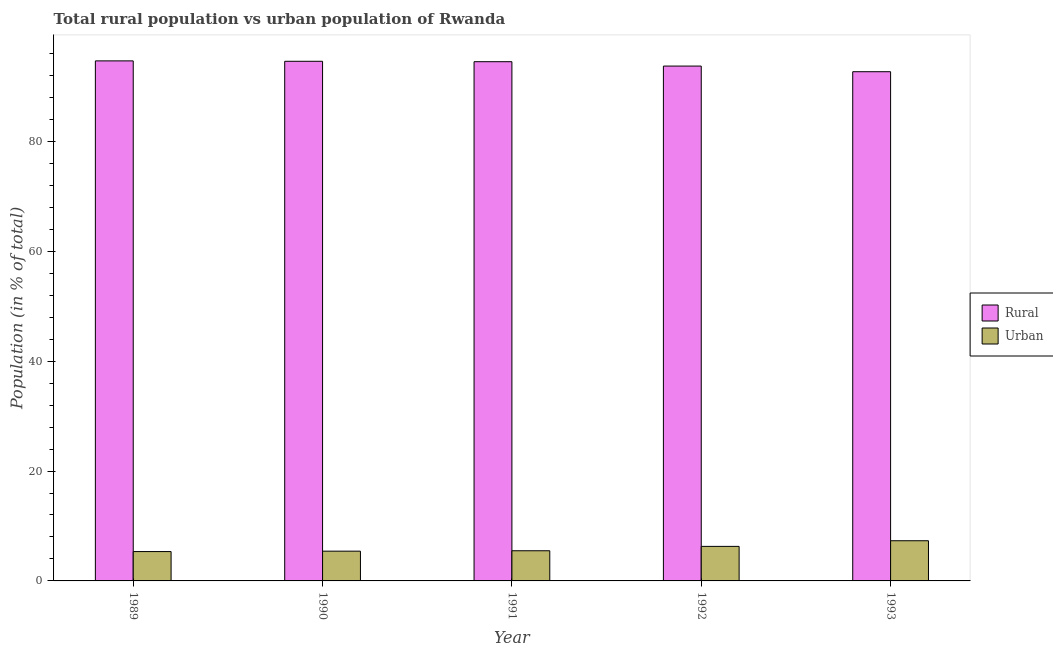How many different coloured bars are there?
Your answer should be compact. 2. How many groups of bars are there?
Give a very brief answer. 5. What is the rural population in 1991?
Keep it short and to the point. 94.51. Across all years, what is the maximum rural population?
Offer a terse response. 94.66. Across all years, what is the minimum urban population?
Provide a succinct answer. 5.34. In which year was the urban population minimum?
Provide a succinct answer. 1989. What is the total urban population in the graph?
Ensure brevity in your answer.  29.85. What is the difference between the rural population in 1992 and that in 1993?
Offer a very short reply. 1.03. What is the difference between the rural population in 1990 and the urban population in 1992?
Offer a terse response. 0.87. What is the average urban population per year?
Make the answer very short. 5.97. In how many years, is the urban population greater than 52 %?
Your response must be concise. 0. What is the ratio of the rural population in 1989 to that in 1993?
Offer a terse response. 1.02. What is the difference between the highest and the second highest rural population?
Your answer should be very brief. 0.07. What is the difference between the highest and the lowest rural population?
Your answer should be compact. 1.97. Is the sum of the urban population in 1989 and 1990 greater than the maximum rural population across all years?
Provide a succinct answer. Yes. What does the 1st bar from the left in 1991 represents?
Offer a very short reply. Rural. What does the 2nd bar from the right in 1991 represents?
Provide a succinct answer. Rural. How many bars are there?
Your response must be concise. 10. Are all the bars in the graph horizontal?
Ensure brevity in your answer.  No. What is the difference between two consecutive major ticks on the Y-axis?
Provide a short and direct response. 20. Are the values on the major ticks of Y-axis written in scientific E-notation?
Ensure brevity in your answer.  No. Does the graph contain any zero values?
Keep it short and to the point. No. Does the graph contain grids?
Offer a terse response. No. What is the title of the graph?
Make the answer very short. Total rural population vs urban population of Rwanda. What is the label or title of the Y-axis?
Offer a terse response. Population (in % of total). What is the Population (in % of total) in Rural in 1989?
Your response must be concise. 94.66. What is the Population (in % of total) of Urban in 1989?
Offer a very short reply. 5.34. What is the Population (in % of total) of Rural in 1990?
Your answer should be compact. 94.58. What is the Population (in % of total) in Urban in 1990?
Offer a very short reply. 5.42. What is the Population (in % of total) in Rural in 1991?
Your response must be concise. 94.51. What is the Population (in % of total) of Urban in 1991?
Your answer should be compact. 5.49. What is the Population (in % of total) in Rural in 1992?
Keep it short and to the point. 93.71. What is the Population (in % of total) of Urban in 1992?
Offer a very short reply. 6.29. What is the Population (in % of total) in Rural in 1993?
Give a very brief answer. 92.69. What is the Population (in % of total) in Urban in 1993?
Ensure brevity in your answer.  7.31. Across all years, what is the maximum Population (in % of total) of Rural?
Provide a short and direct response. 94.66. Across all years, what is the maximum Population (in % of total) of Urban?
Your response must be concise. 7.31. Across all years, what is the minimum Population (in % of total) in Rural?
Provide a succinct answer. 92.69. Across all years, what is the minimum Population (in % of total) in Urban?
Give a very brief answer. 5.34. What is the total Population (in % of total) in Rural in the graph?
Your answer should be compact. 470.15. What is the total Population (in % of total) of Urban in the graph?
Your response must be concise. 29.85. What is the difference between the Population (in % of total) of Rural in 1989 and that in 1990?
Your answer should be compact. 0.07. What is the difference between the Population (in % of total) of Urban in 1989 and that in 1990?
Provide a short and direct response. -0.07. What is the difference between the Population (in % of total) in Rural in 1989 and that in 1991?
Give a very brief answer. 0.15. What is the difference between the Population (in % of total) of Urban in 1989 and that in 1991?
Provide a short and direct response. -0.15. What is the difference between the Population (in % of total) in Rural in 1989 and that in 1992?
Your answer should be very brief. 0.95. What is the difference between the Population (in % of total) in Urban in 1989 and that in 1992?
Ensure brevity in your answer.  -0.95. What is the difference between the Population (in % of total) in Rural in 1989 and that in 1993?
Your answer should be very brief. 1.97. What is the difference between the Population (in % of total) in Urban in 1989 and that in 1993?
Your answer should be compact. -1.97. What is the difference between the Population (in % of total) of Rural in 1990 and that in 1991?
Your answer should be very brief. 0.07. What is the difference between the Population (in % of total) in Urban in 1990 and that in 1991?
Your answer should be compact. -0.07. What is the difference between the Population (in % of total) of Rural in 1990 and that in 1992?
Ensure brevity in your answer.  0.87. What is the difference between the Population (in % of total) in Urban in 1990 and that in 1992?
Ensure brevity in your answer.  -0.87. What is the difference between the Population (in % of total) of Rural in 1990 and that in 1993?
Offer a terse response. 1.9. What is the difference between the Population (in % of total) in Urban in 1990 and that in 1993?
Provide a short and direct response. -1.9. What is the difference between the Population (in % of total) in Rural in 1991 and that in 1992?
Keep it short and to the point. 0.8. What is the difference between the Population (in % of total) of Urban in 1991 and that in 1992?
Offer a terse response. -0.8. What is the difference between the Population (in % of total) in Rural in 1991 and that in 1993?
Give a very brief answer. 1.82. What is the difference between the Population (in % of total) of Urban in 1991 and that in 1993?
Your response must be concise. -1.82. What is the difference between the Population (in % of total) in Rural in 1992 and that in 1993?
Make the answer very short. 1.02. What is the difference between the Population (in % of total) in Urban in 1992 and that in 1993?
Your answer should be compact. -1.02. What is the difference between the Population (in % of total) in Rural in 1989 and the Population (in % of total) in Urban in 1990?
Your response must be concise. 89.24. What is the difference between the Population (in % of total) in Rural in 1989 and the Population (in % of total) in Urban in 1991?
Your response must be concise. 89.17. What is the difference between the Population (in % of total) of Rural in 1989 and the Population (in % of total) of Urban in 1992?
Your answer should be very brief. 88.37. What is the difference between the Population (in % of total) of Rural in 1989 and the Population (in % of total) of Urban in 1993?
Make the answer very short. 87.34. What is the difference between the Population (in % of total) in Rural in 1990 and the Population (in % of total) in Urban in 1991?
Provide a short and direct response. 89.09. What is the difference between the Population (in % of total) in Rural in 1990 and the Population (in % of total) in Urban in 1992?
Ensure brevity in your answer.  88.3. What is the difference between the Population (in % of total) in Rural in 1990 and the Population (in % of total) in Urban in 1993?
Keep it short and to the point. 87.27. What is the difference between the Population (in % of total) in Rural in 1991 and the Population (in % of total) in Urban in 1992?
Your answer should be compact. 88.22. What is the difference between the Population (in % of total) of Rural in 1991 and the Population (in % of total) of Urban in 1993?
Offer a terse response. 87.2. What is the difference between the Population (in % of total) in Rural in 1992 and the Population (in % of total) in Urban in 1993?
Provide a succinct answer. 86.4. What is the average Population (in % of total) in Rural per year?
Offer a very short reply. 94.03. What is the average Population (in % of total) in Urban per year?
Keep it short and to the point. 5.97. In the year 1989, what is the difference between the Population (in % of total) in Rural and Population (in % of total) in Urban?
Ensure brevity in your answer.  89.32. In the year 1990, what is the difference between the Population (in % of total) in Rural and Population (in % of total) in Urban?
Offer a terse response. 89.17. In the year 1991, what is the difference between the Population (in % of total) of Rural and Population (in % of total) of Urban?
Keep it short and to the point. 89.02. In the year 1992, what is the difference between the Population (in % of total) of Rural and Population (in % of total) of Urban?
Ensure brevity in your answer.  87.42. In the year 1993, what is the difference between the Population (in % of total) in Rural and Population (in % of total) in Urban?
Your answer should be compact. 85.37. What is the ratio of the Population (in % of total) of Urban in 1989 to that in 1990?
Your answer should be very brief. 0.99. What is the ratio of the Population (in % of total) in Rural in 1989 to that in 1991?
Keep it short and to the point. 1. What is the ratio of the Population (in % of total) of Urban in 1989 to that in 1991?
Provide a short and direct response. 0.97. What is the ratio of the Population (in % of total) of Rural in 1989 to that in 1992?
Provide a short and direct response. 1.01. What is the ratio of the Population (in % of total) in Urban in 1989 to that in 1992?
Your response must be concise. 0.85. What is the ratio of the Population (in % of total) in Rural in 1989 to that in 1993?
Make the answer very short. 1.02. What is the ratio of the Population (in % of total) of Urban in 1989 to that in 1993?
Offer a very short reply. 0.73. What is the ratio of the Population (in % of total) in Rural in 1990 to that in 1991?
Your answer should be very brief. 1. What is the ratio of the Population (in % of total) in Urban in 1990 to that in 1991?
Offer a terse response. 0.99. What is the ratio of the Population (in % of total) of Rural in 1990 to that in 1992?
Your answer should be compact. 1.01. What is the ratio of the Population (in % of total) in Urban in 1990 to that in 1992?
Provide a short and direct response. 0.86. What is the ratio of the Population (in % of total) of Rural in 1990 to that in 1993?
Give a very brief answer. 1.02. What is the ratio of the Population (in % of total) of Urban in 1990 to that in 1993?
Make the answer very short. 0.74. What is the ratio of the Population (in % of total) in Rural in 1991 to that in 1992?
Your answer should be compact. 1.01. What is the ratio of the Population (in % of total) of Urban in 1991 to that in 1992?
Give a very brief answer. 0.87. What is the ratio of the Population (in % of total) in Rural in 1991 to that in 1993?
Your answer should be very brief. 1.02. What is the ratio of the Population (in % of total) in Urban in 1991 to that in 1993?
Make the answer very short. 0.75. What is the ratio of the Population (in % of total) in Rural in 1992 to that in 1993?
Provide a succinct answer. 1.01. What is the ratio of the Population (in % of total) in Urban in 1992 to that in 1993?
Offer a very short reply. 0.86. What is the difference between the highest and the second highest Population (in % of total) of Rural?
Your answer should be very brief. 0.07. What is the difference between the highest and the second highest Population (in % of total) of Urban?
Your answer should be very brief. 1.02. What is the difference between the highest and the lowest Population (in % of total) in Rural?
Provide a short and direct response. 1.97. What is the difference between the highest and the lowest Population (in % of total) of Urban?
Offer a terse response. 1.97. 